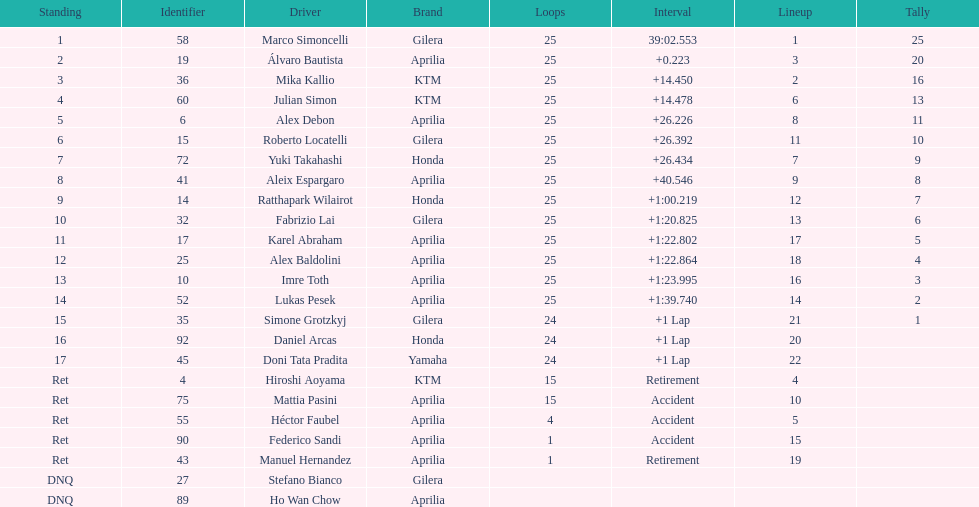Did marco simoncelli or alvaro bautista held rank 1? Marco Simoncelli. 